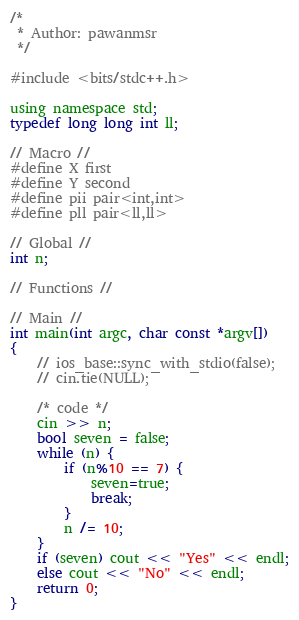<code> <loc_0><loc_0><loc_500><loc_500><_C_>/* 
 * Author: pawanmsr
 */

#include <bits/stdc++.h>

using namespace std;
typedef long long int ll;

// Macro //
#define X first
#define Y second
#define pii pair<int,int>
#define pll pair<ll,ll>

// Global //
int n;

// Functions //

// Main //
int main(int argc, char const *argv[])
{
    // ios_base::sync_with_stdio(false);
    // cin.tie(NULL);
    
    /* code */
    cin >> n;
    bool seven = false;
    while (n) {
        if (n%10 == 7) {
            seven=true;
            break;
        }
        n /= 10;
    }
    if (seven) cout << "Yes" << endl;
    else cout << "No" << endl;
    return 0;
}
</code> 